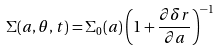<formula> <loc_0><loc_0><loc_500><loc_500>\Sigma ( a , \theta , t ) = \Sigma _ { 0 } ( a ) \left ( 1 + \frac { \partial \delta r } { \partial a } \right ) ^ { - 1 }</formula> 